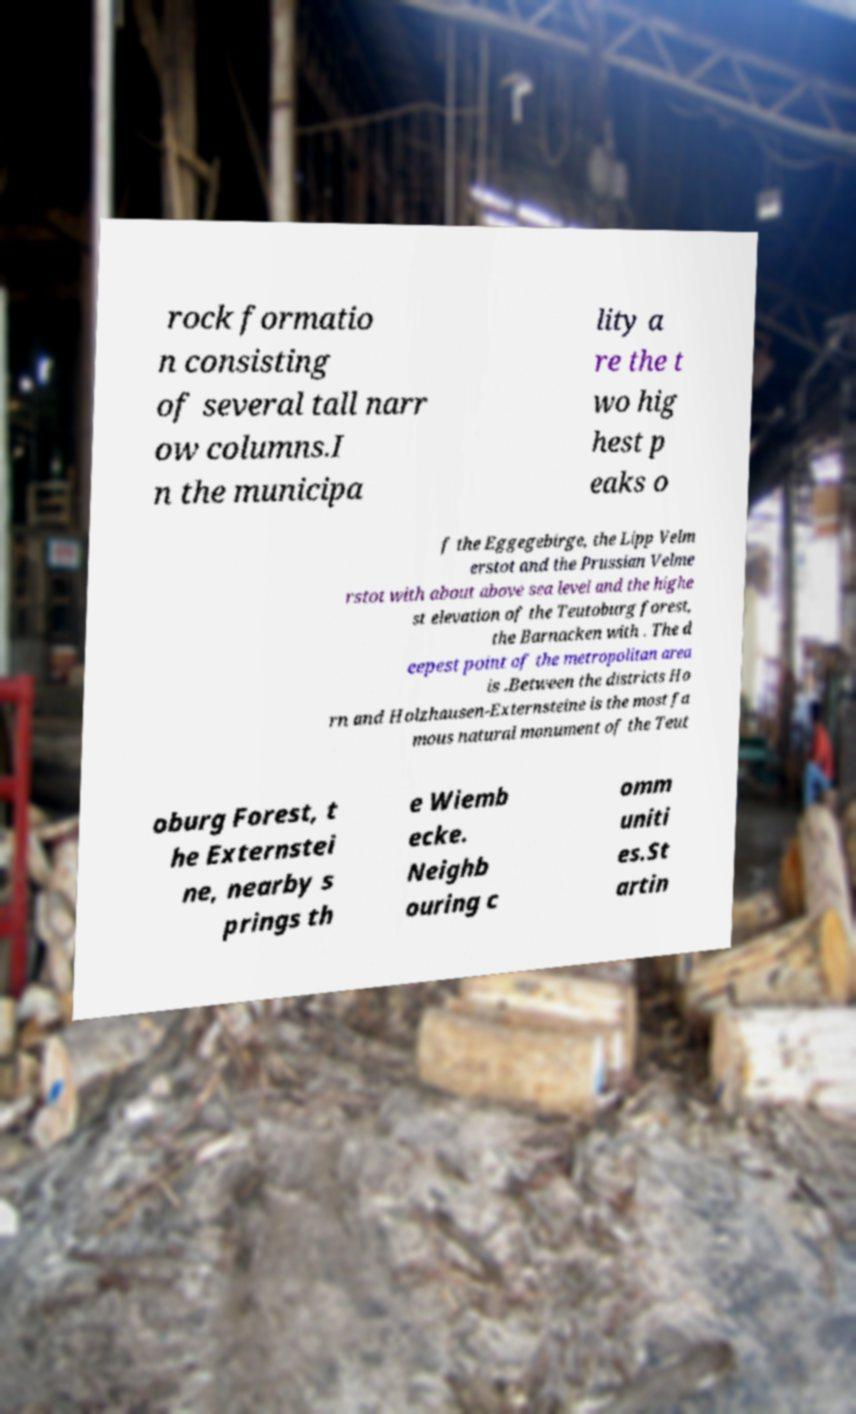Can you accurately transcribe the text from the provided image for me? rock formatio n consisting of several tall narr ow columns.I n the municipa lity a re the t wo hig hest p eaks o f the Eggegebirge, the Lipp Velm erstot and the Prussian Velme rstot with about above sea level and the highe st elevation of the Teutoburg forest, the Barnacken with . The d eepest point of the metropolitan area is .Between the districts Ho rn and Holzhausen-Externsteine is the most fa mous natural monument of the Teut oburg Forest, t he Externstei ne, nearby s prings th e Wiemb ecke. Neighb ouring c omm uniti es.St artin 